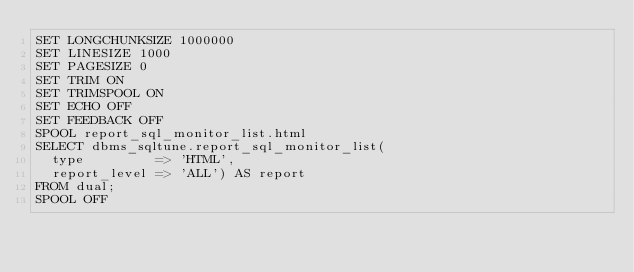<code> <loc_0><loc_0><loc_500><loc_500><_SQL_>SET LONGCHUNKSIZE 1000000
SET LINESIZE 1000
SET PAGESIZE 0
SET TRIM ON
SET TRIMSPOOL ON
SET ECHO OFF
SET FEEDBACK OFF
SPOOL report_sql_monitor_list.html
SELECT dbms_sqltune.report_sql_monitor_list(
  type         => 'HTML',
  report_level => 'ALL') AS report
FROM dual;
SPOOL OFF
</code> 